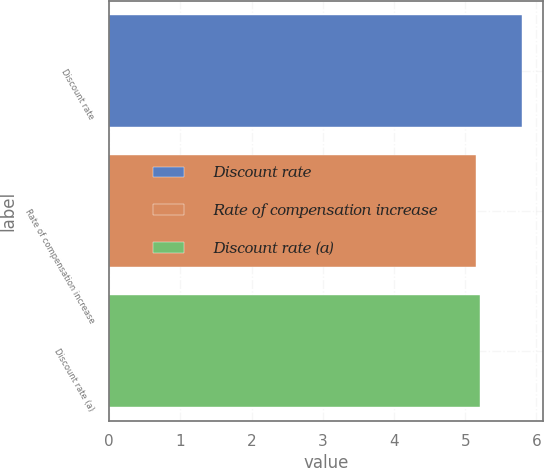Convert chart. <chart><loc_0><loc_0><loc_500><loc_500><bar_chart><fcel>Discount rate<fcel>Rate of compensation increase<fcel>Discount rate (a)<nl><fcel>5.8<fcel>5.15<fcel>5.21<nl></chart> 